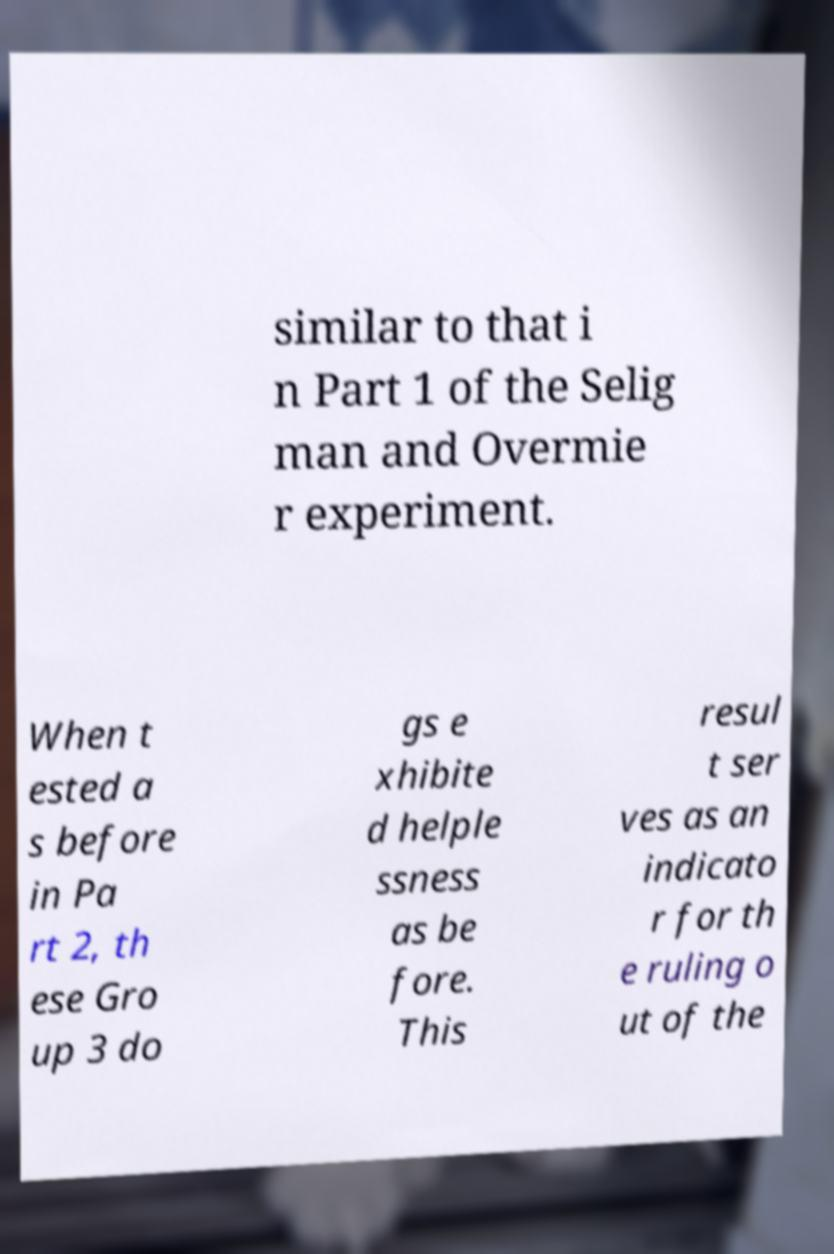Could you extract and type out the text from this image? similar to that i n Part 1 of the Selig man and Overmie r experiment. When t ested a s before in Pa rt 2, th ese Gro up 3 do gs e xhibite d helple ssness as be fore. This resul t ser ves as an indicato r for th e ruling o ut of the 